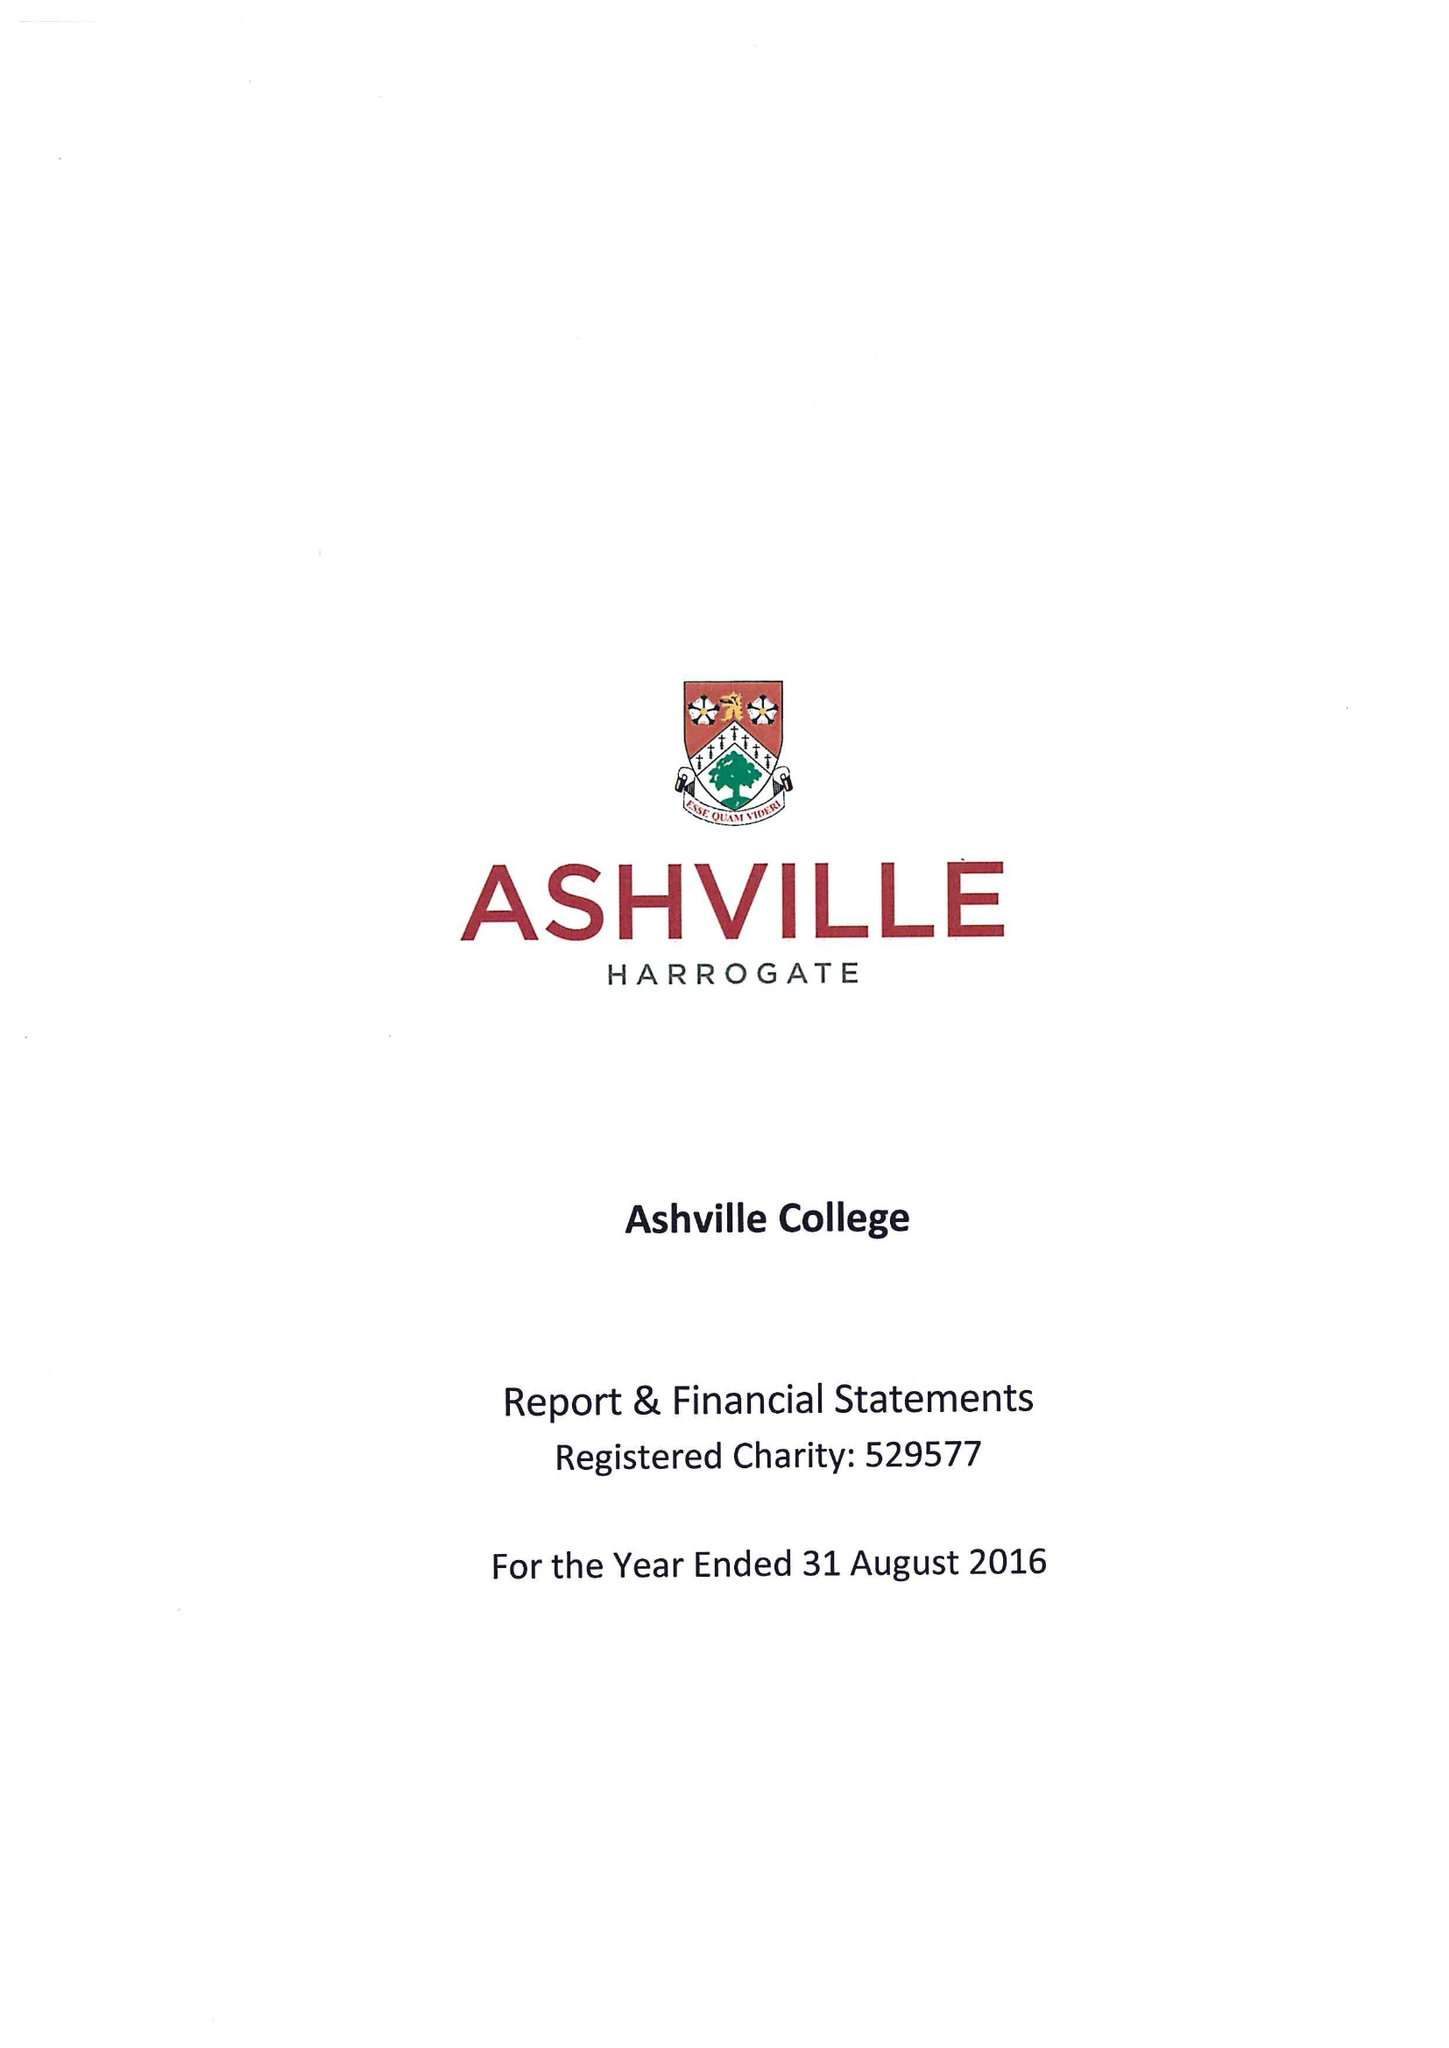What is the value for the charity_name?
Answer the question using a single word or phrase. Ashville College 